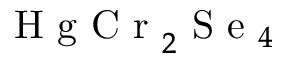<formula> <loc_0><loc_0><loc_500><loc_500>H g C r _ { 2 } S e _ { 4 }</formula> 